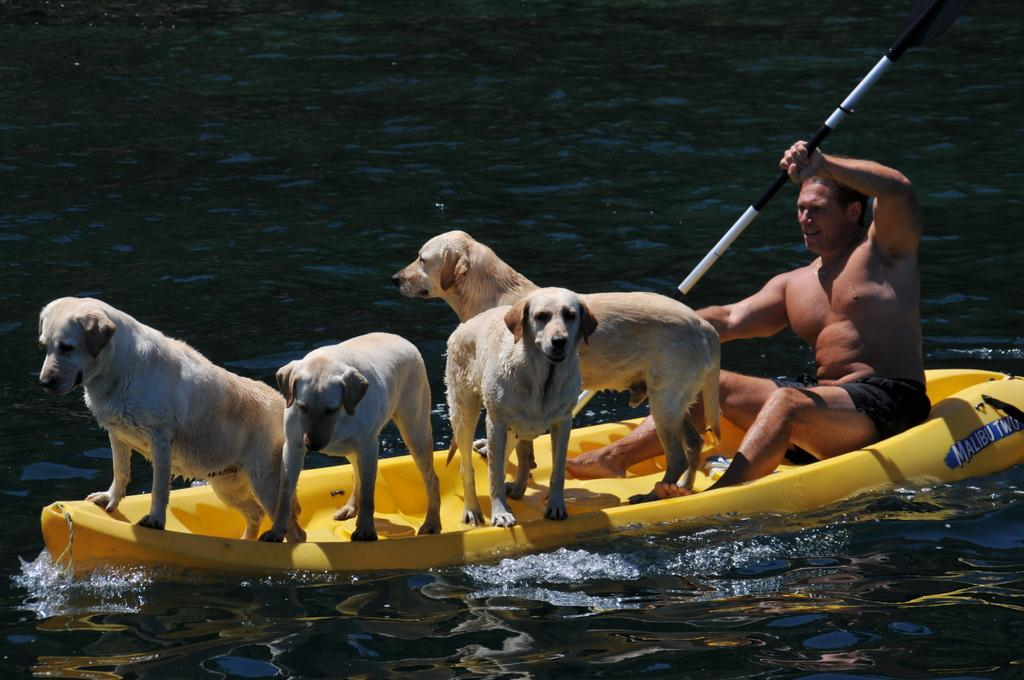What is at the bottom of the image? There is water at the bottom of the image. What can be seen floating on the water? There is a canoe in the image. What is the person in the image doing? The person is holding an object in the image. What type of animals are in the foreground of the image? There are animals in the foreground of the image. What type of pies can be seen in the image? There are no pies present in the image. How many toes does the person in the image have? The number of toes on the person in the image cannot be determined from the image alone. 